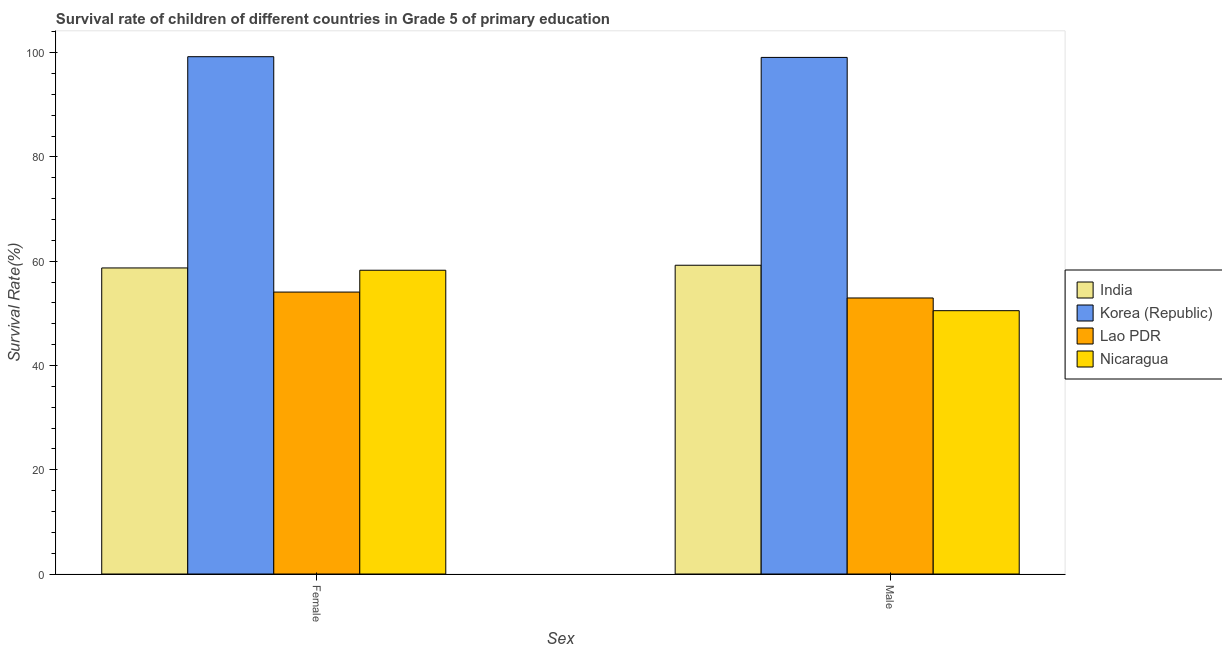How many groups of bars are there?
Make the answer very short. 2. Are the number of bars on each tick of the X-axis equal?
Your answer should be very brief. Yes. How many bars are there on the 1st tick from the left?
Ensure brevity in your answer.  4. How many bars are there on the 2nd tick from the right?
Provide a succinct answer. 4. What is the survival rate of female students in primary education in Nicaragua?
Offer a terse response. 58.27. Across all countries, what is the maximum survival rate of male students in primary education?
Your response must be concise. 99.1. Across all countries, what is the minimum survival rate of male students in primary education?
Give a very brief answer. 50.51. In which country was the survival rate of female students in primary education maximum?
Offer a very short reply. Korea (Republic). In which country was the survival rate of female students in primary education minimum?
Offer a very short reply. Lao PDR. What is the total survival rate of male students in primary education in the graph?
Offer a very short reply. 261.8. What is the difference between the survival rate of female students in primary education in Nicaragua and that in India?
Ensure brevity in your answer.  -0.44. What is the difference between the survival rate of female students in primary education in Lao PDR and the survival rate of male students in primary education in Nicaragua?
Offer a very short reply. 3.57. What is the average survival rate of female students in primary education per country?
Provide a short and direct response. 67.58. What is the difference between the survival rate of female students in primary education and survival rate of male students in primary education in India?
Give a very brief answer. -0.52. What is the ratio of the survival rate of female students in primary education in India to that in Korea (Republic)?
Provide a short and direct response. 0.59. Is the survival rate of female students in primary education in India less than that in Nicaragua?
Provide a succinct answer. No. What does the 3rd bar from the left in Male represents?
Your response must be concise. Lao PDR. What does the 1st bar from the right in Female represents?
Your answer should be very brief. Nicaragua. How many bars are there?
Provide a succinct answer. 8. Are all the bars in the graph horizontal?
Ensure brevity in your answer.  No. What is the difference between two consecutive major ticks on the Y-axis?
Give a very brief answer. 20. Are the values on the major ticks of Y-axis written in scientific E-notation?
Your answer should be very brief. No. Does the graph contain any zero values?
Keep it short and to the point. No. Does the graph contain grids?
Give a very brief answer. No. Where does the legend appear in the graph?
Provide a succinct answer. Center right. What is the title of the graph?
Give a very brief answer. Survival rate of children of different countries in Grade 5 of primary education. What is the label or title of the X-axis?
Your response must be concise. Sex. What is the label or title of the Y-axis?
Offer a terse response. Survival Rate(%). What is the Survival Rate(%) in India in Female?
Your answer should be compact. 58.71. What is the Survival Rate(%) in Korea (Republic) in Female?
Give a very brief answer. 99.24. What is the Survival Rate(%) in Lao PDR in Female?
Keep it short and to the point. 54.09. What is the Survival Rate(%) in Nicaragua in Female?
Offer a very short reply. 58.27. What is the Survival Rate(%) of India in Male?
Keep it short and to the point. 59.23. What is the Survival Rate(%) in Korea (Republic) in Male?
Offer a terse response. 99.1. What is the Survival Rate(%) in Lao PDR in Male?
Keep it short and to the point. 52.95. What is the Survival Rate(%) in Nicaragua in Male?
Make the answer very short. 50.51. Across all Sex, what is the maximum Survival Rate(%) of India?
Give a very brief answer. 59.23. Across all Sex, what is the maximum Survival Rate(%) of Korea (Republic)?
Keep it short and to the point. 99.24. Across all Sex, what is the maximum Survival Rate(%) of Lao PDR?
Your answer should be very brief. 54.09. Across all Sex, what is the maximum Survival Rate(%) in Nicaragua?
Your answer should be compact. 58.27. Across all Sex, what is the minimum Survival Rate(%) in India?
Ensure brevity in your answer.  58.71. Across all Sex, what is the minimum Survival Rate(%) of Korea (Republic)?
Your response must be concise. 99.1. Across all Sex, what is the minimum Survival Rate(%) in Lao PDR?
Offer a very short reply. 52.95. Across all Sex, what is the minimum Survival Rate(%) of Nicaragua?
Your answer should be very brief. 50.51. What is the total Survival Rate(%) of India in the graph?
Offer a very short reply. 117.95. What is the total Survival Rate(%) in Korea (Republic) in the graph?
Provide a succinct answer. 198.34. What is the total Survival Rate(%) of Lao PDR in the graph?
Keep it short and to the point. 107.04. What is the total Survival Rate(%) of Nicaragua in the graph?
Provide a short and direct response. 108.79. What is the difference between the Survival Rate(%) in India in Female and that in Male?
Ensure brevity in your answer.  -0.52. What is the difference between the Survival Rate(%) in Korea (Republic) in Female and that in Male?
Make the answer very short. 0.14. What is the difference between the Survival Rate(%) of Lao PDR in Female and that in Male?
Keep it short and to the point. 1.13. What is the difference between the Survival Rate(%) of Nicaragua in Female and that in Male?
Your answer should be very brief. 7.76. What is the difference between the Survival Rate(%) of India in Female and the Survival Rate(%) of Korea (Republic) in Male?
Offer a terse response. -40.39. What is the difference between the Survival Rate(%) of India in Female and the Survival Rate(%) of Lao PDR in Male?
Your answer should be very brief. 5.76. What is the difference between the Survival Rate(%) of India in Female and the Survival Rate(%) of Nicaragua in Male?
Keep it short and to the point. 8.2. What is the difference between the Survival Rate(%) of Korea (Republic) in Female and the Survival Rate(%) of Lao PDR in Male?
Ensure brevity in your answer.  46.29. What is the difference between the Survival Rate(%) in Korea (Republic) in Female and the Survival Rate(%) in Nicaragua in Male?
Provide a short and direct response. 48.73. What is the difference between the Survival Rate(%) of Lao PDR in Female and the Survival Rate(%) of Nicaragua in Male?
Ensure brevity in your answer.  3.57. What is the average Survival Rate(%) of India per Sex?
Provide a succinct answer. 58.97. What is the average Survival Rate(%) in Korea (Republic) per Sex?
Make the answer very short. 99.17. What is the average Survival Rate(%) of Lao PDR per Sex?
Offer a very short reply. 53.52. What is the average Survival Rate(%) of Nicaragua per Sex?
Your response must be concise. 54.39. What is the difference between the Survival Rate(%) of India and Survival Rate(%) of Korea (Republic) in Female?
Ensure brevity in your answer.  -40.53. What is the difference between the Survival Rate(%) in India and Survival Rate(%) in Lao PDR in Female?
Your answer should be very brief. 4.63. What is the difference between the Survival Rate(%) in India and Survival Rate(%) in Nicaragua in Female?
Offer a terse response. 0.44. What is the difference between the Survival Rate(%) in Korea (Republic) and Survival Rate(%) in Lao PDR in Female?
Keep it short and to the point. 45.15. What is the difference between the Survival Rate(%) of Korea (Republic) and Survival Rate(%) of Nicaragua in Female?
Provide a short and direct response. 40.97. What is the difference between the Survival Rate(%) of Lao PDR and Survival Rate(%) of Nicaragua in Female?
Your answer should be very brief. -4.19. What is the difference between the Survival Rate(%) of India and Survival Rate(%) of Korea (Republic) in Male?
Give a very brief answer. -39.87. What is the difference between the Survival Rate(%) in India and Survival Rate(%) in Lao PDR in Male?
Provide a short and direct response. 6.28. What is the difference between the Survival Rate(%) in India and Survival Rate(%) in Nicaragua in Male?
Give a very brief answer. 8.72. What is the difference between the Survival Rate(%) of Korea (Republic) and Survival Rate(%) of Lao PDR in Male?
Make the answer very short. 46.15. What is the difference between the Survival Rate(%) in Korea (Republic) and Survival Rate(%) in Nicaragua in Male?
Offer a very short reply. 48.59. What is the difference between the Survival Rate(%) of Lao PDR and Survival Rate(%) of Nicaragua in Male?
Keep it short and to the point. 2.44. What is the ratio of the Survival Rate(%) in Korea (Republic) in Female to that in Male?
Ensure brevity in your answer.  1. What is the ratio of the Survival Rate(%) in Lao PDR in Female to that in Male?
Make the answer very short. 1.02. What is the ratio of the Survival Rate(%) in Nicaragua in Female to that in Male?
Give a very brief answer. 1.15. What is the difference between the highest and the second highest Survival Rate(%) of India?
Offer a terse response. 0.52. What is the difference between the highest and the second highest Survival Rate(%) of Korea (Republic)?
Offer a very short reply. 0.14. What is the difference between the highest and the second highest Survival Rate(%) in Lao PDR?
Provide a succinct answer. 1.13. What is the difference between the highest and the second highest Survival Rate(%) in Nicaragua?
Make the answer very short. 7.76. What is the difference between the highest and the lowest Survival Rate(%) of India?
Give a very brief answer. 0.52. What is the difference between the highest and the lowest Survival Rate(%) of Korea (Republic)?
Provide a succinct answer. 0.14. What is the difference between the highest and the lowest Survival Rate(%) in Lao PDR?
Your answer should be very brief. 1.13. What is the difference between the highest and the lowest Survival Rate(%) in Nicaragua?
Give a very brief answer. 7.76. 